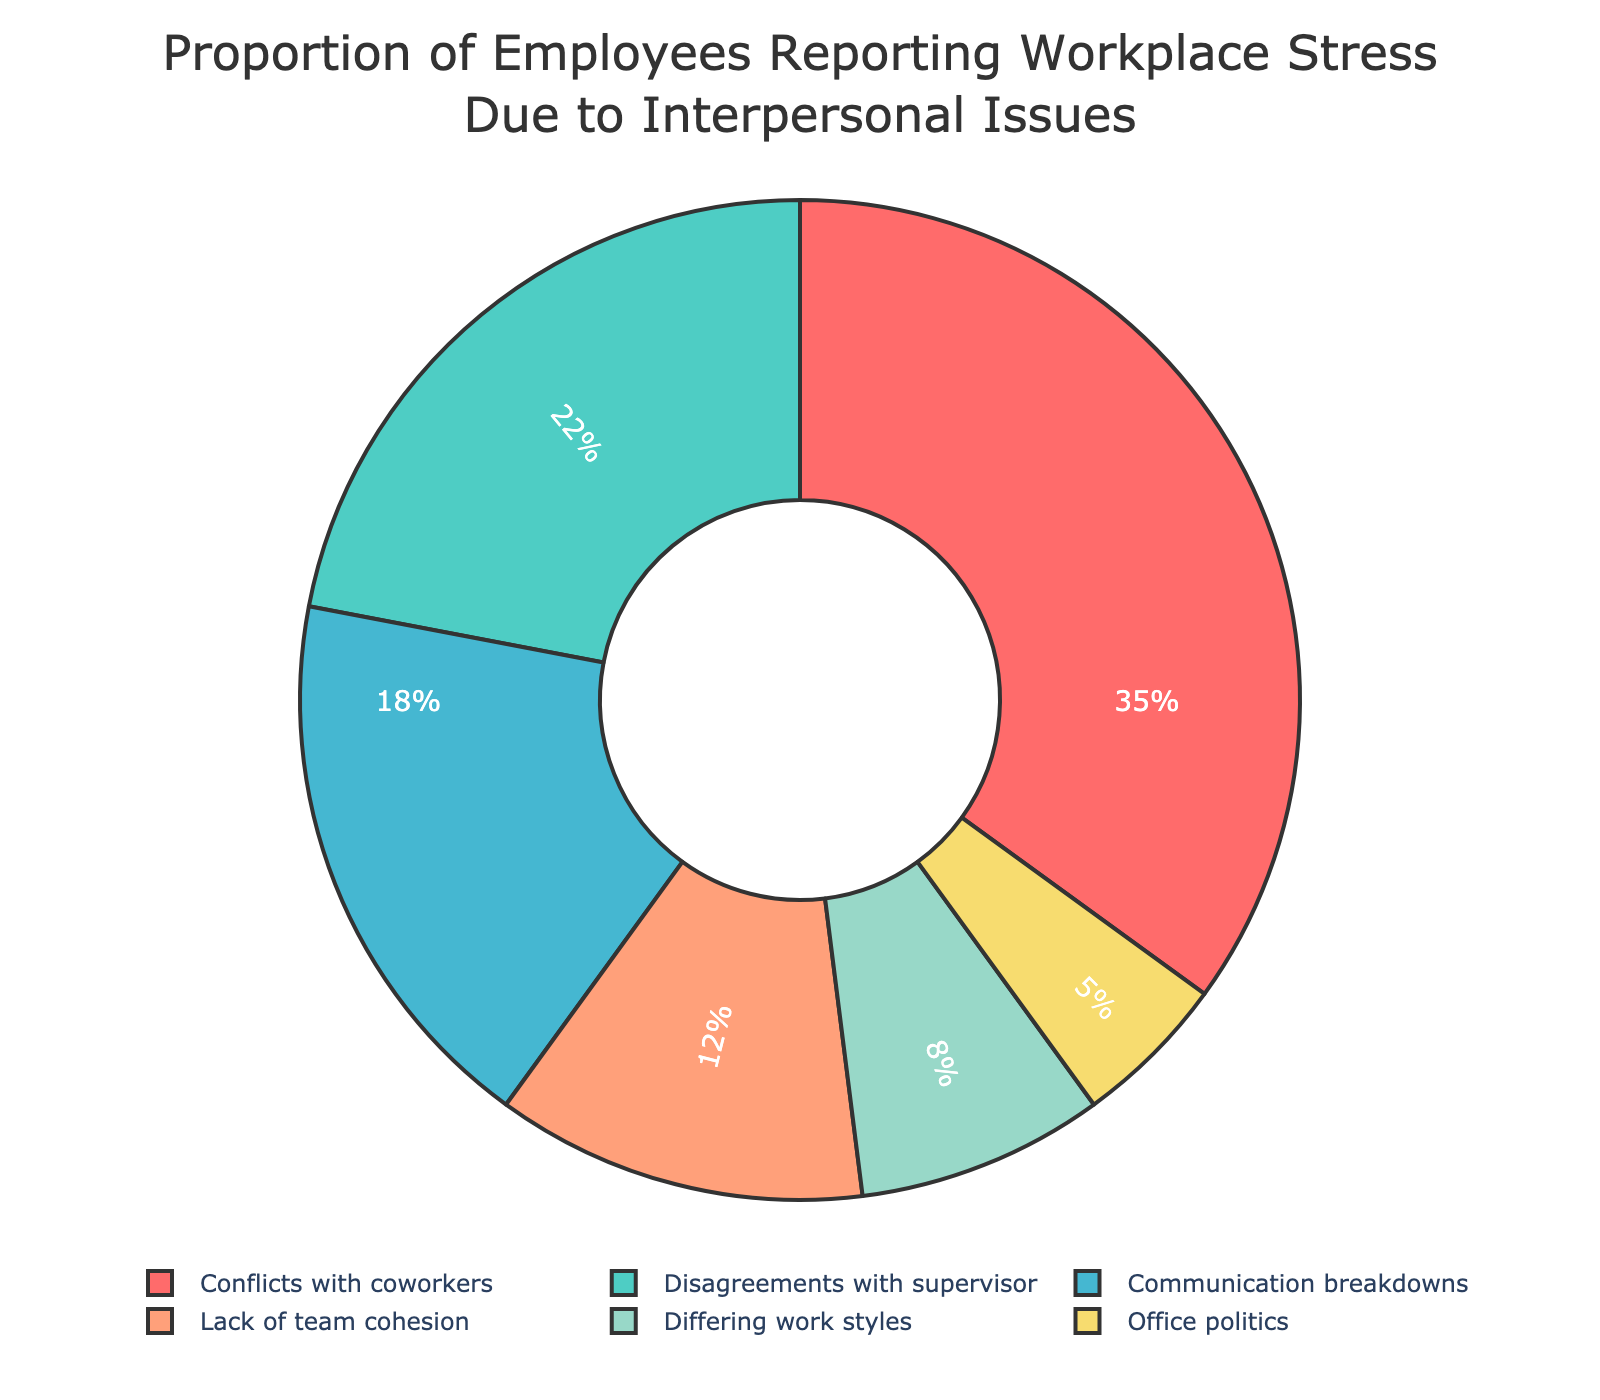What is the largest single cause of workplace stress related to interpersonal issues? The figure shows the different causes of workplace stress with their respective percentages. Looking at the largest segment, we see that "Conflicts with coworkers" occupies 35% of the total, making it the largest cause.
Answer: Conflicts with coworkers What proportion of employees report stress due to disagreements with their supervisor? In the pie chart, the slice labeled "Disagreements with supervisor" shows the percentage directly. That slice represents 22% of the total.
Answer: 22% Which causes contribute less than 10% to workplace stress? Observing the chart, we identify segments smaller than 10%. These are "Differing work styles" at 8% and "Office politics" at 5%.
Answer: Differing work styles, Office politics What is the percentage difference between "Conflicts with coworkers" and "Communication breakdowns"? The chart shows "Conflicts with coworkers" at 35% and "Communication breakdowns" at 18%. The difference is calculated as 35% - 18% = 17%.
Answer: 17% What is the combined percentage of employees reporting stress due to "Lack of team cohesion" and "Office politics"? These two causes show percentages of 12% and 5% respectively. Adding these together, we get 12% + 5% = 17%.
Answer: 17% How does the percentage of stress due to "Differing work styles" compare to "Lack of team cohesion"? According to the chart, "Differing work styles" is 8%, and "Lack of team cohesion" is 12%. Therefore, "Differing work styles" is 4% less than "Lack of team cohesion".
Answer: 4% less Which cause of workplace stress is represented by the blue segment, and what percentage does it hold? The blue color segment corresponds to "Conflicts with coworkers", which holds the highest percentage at 35% as indicated in the chart.
Answer: Conflicts with coworkers, 35% What proportion of employees report stress due to issues other than "Conflicts with coworkers" and "Disagreements with supervisor"? Summing the percentages of the other categories: Communication breakdowns (18%), Lack of team cohesion (12%), Differing work styles (8%), Office politics (5%). This totals 18% + 12% + 8% + 5% = 43%.
Answer: 43% 